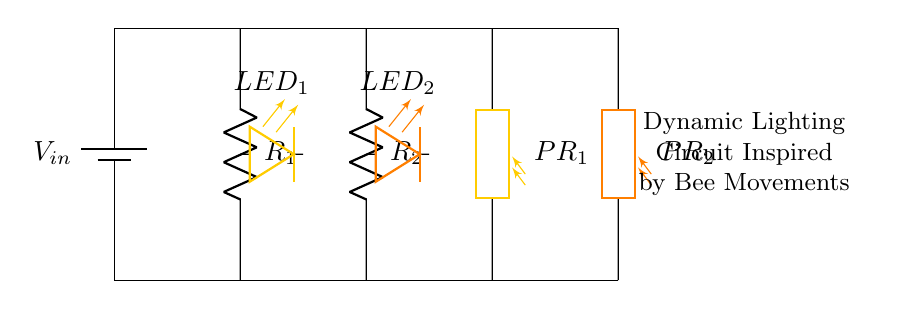What are the resistances in this circuit? The circuit shows two resistors, R1 and R2, along with two photoresistors, PR1 and PR2. There are no specific numeric values indicated for the resistances in the visual.
Answer: R1, R2, PR1, PR2 What colors are the LEDs in this circuit? The circuit includes two LEDs; LED1 is colored bee yellow, and LED2 is colored bee orange. The colors are specified directly in the diagram.
Answer: Bee yellow, bee orange How many photoresistors are present in the circuit? The diagram includes two components labeled as photoresistors, PR1 and PR2, indicating their presence.
Answer: Two What is the purpose of using photoresistors in this circuit? The photoresistors change their resistance based on light intensity, allowing for dynamic lighting effects that can mimic bee movements, responding to environmental changes.
Answer: Dynamic lighting effects What can you conclude about the current distribution in this parallel circuit? In a parallel circuit, the total current divides among the branches; each resistor and photoresistor will receive a portion of the total current according to their resistance values. This is essential for understanding how the circuit behaves under varying light conditions, affecting LED brightness.
Answer: Current divides among branches 